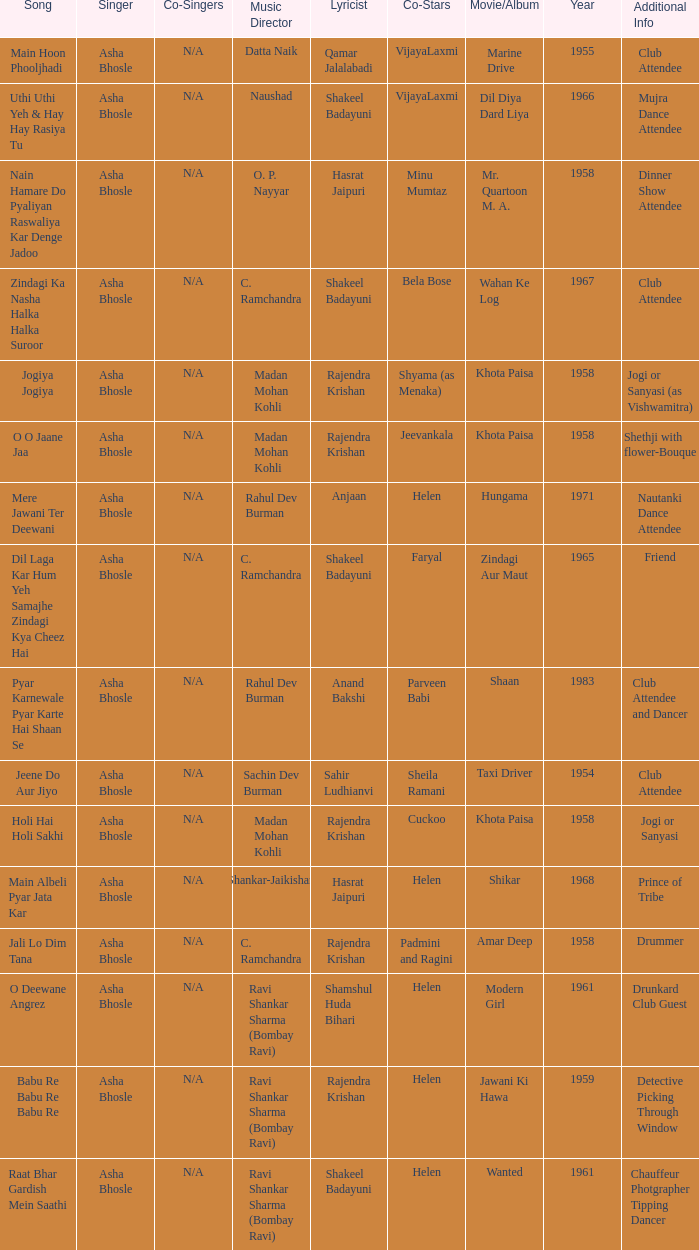In which film did bela bose feature as a co-star? Wahan Ke Log. 